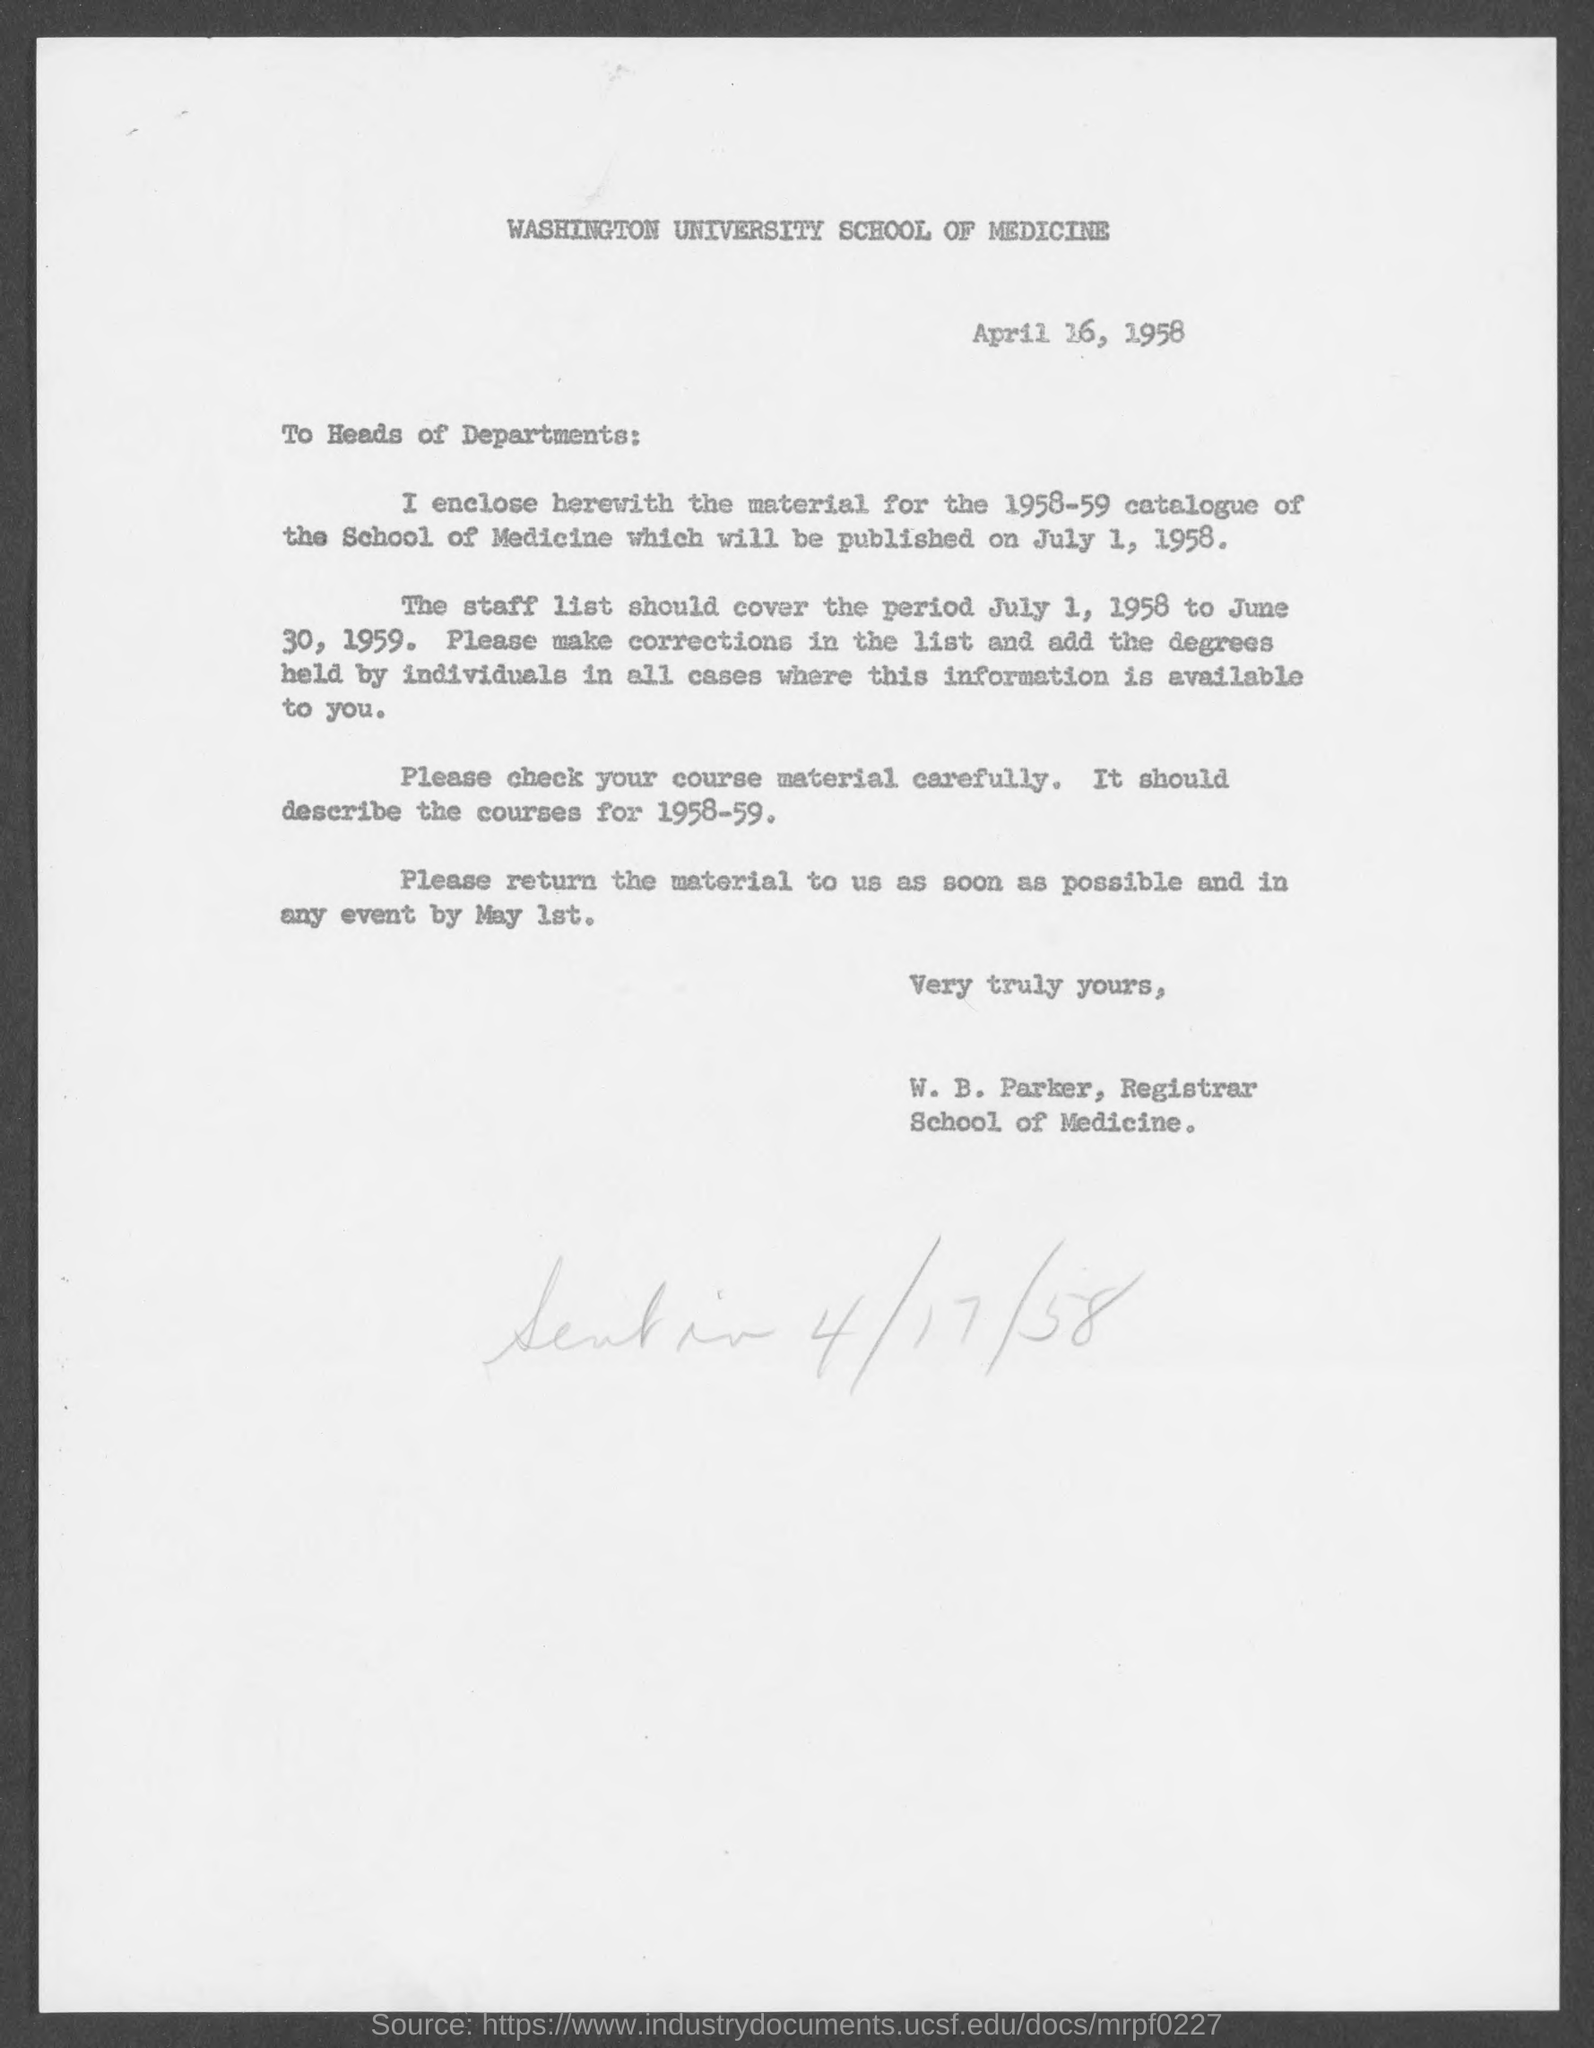Draw attention to some important aspects in this diagram. The salutation of this letter is: 'To Heads of Departments:' 